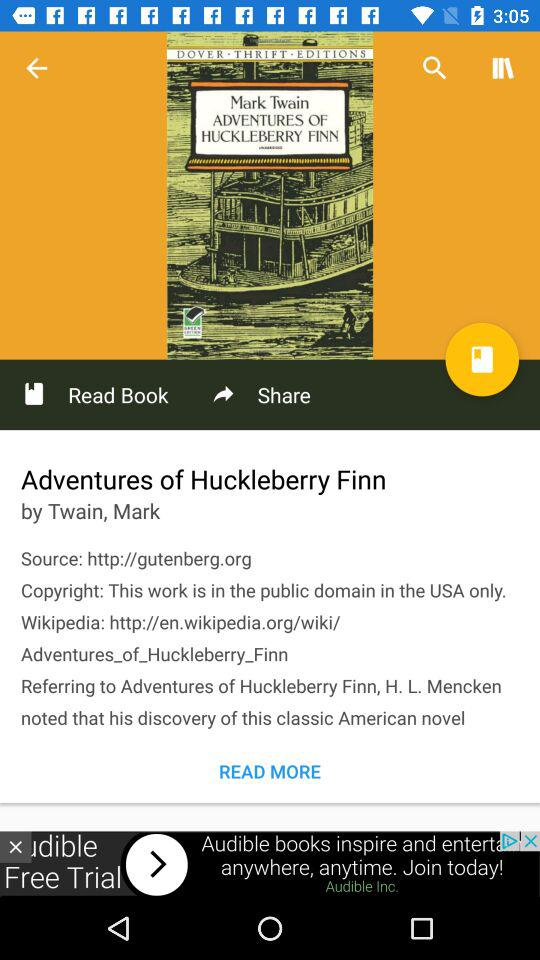What is the source of the website to find out the adventures of Huckleberry Finn? The source of the website is http://gutenberg.org. 